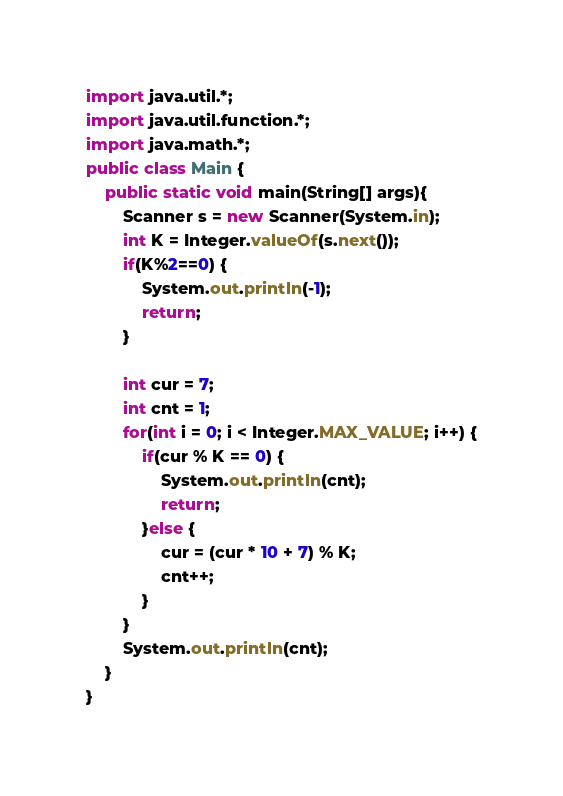<code> <loc_0><loc_0><loc_500><loc_500><_Java_>import java.util.*;
import java.util.function.*;
import java.math.*;
public class Main {
    public static void main(String[] args){
		Scanner s = new Scanner(System.in);
		int K = Integer.valueOf(s.next());
		if(K%2==0) {
			System.out.println(-1);
			return;
		}
		
		int cur = 7;
		int cnt = 1;
		for(int i = 0; i < Integer.MAX_VALUE; i++) {
			if(cur % K == 0) {
				System.out.println(cnt);
				return;
			}else {
				cur = (cur * 10 + 7) % K;
				cnt++;
			}
		}
		System.out.println(cnt);
	}
}</code> 